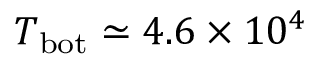<formula> <loc_0><loc_0><loc_500><loc_500>T _ { b o t } \simeq 4 . 6 \times 1 0 ^ { 4 }</formula> 